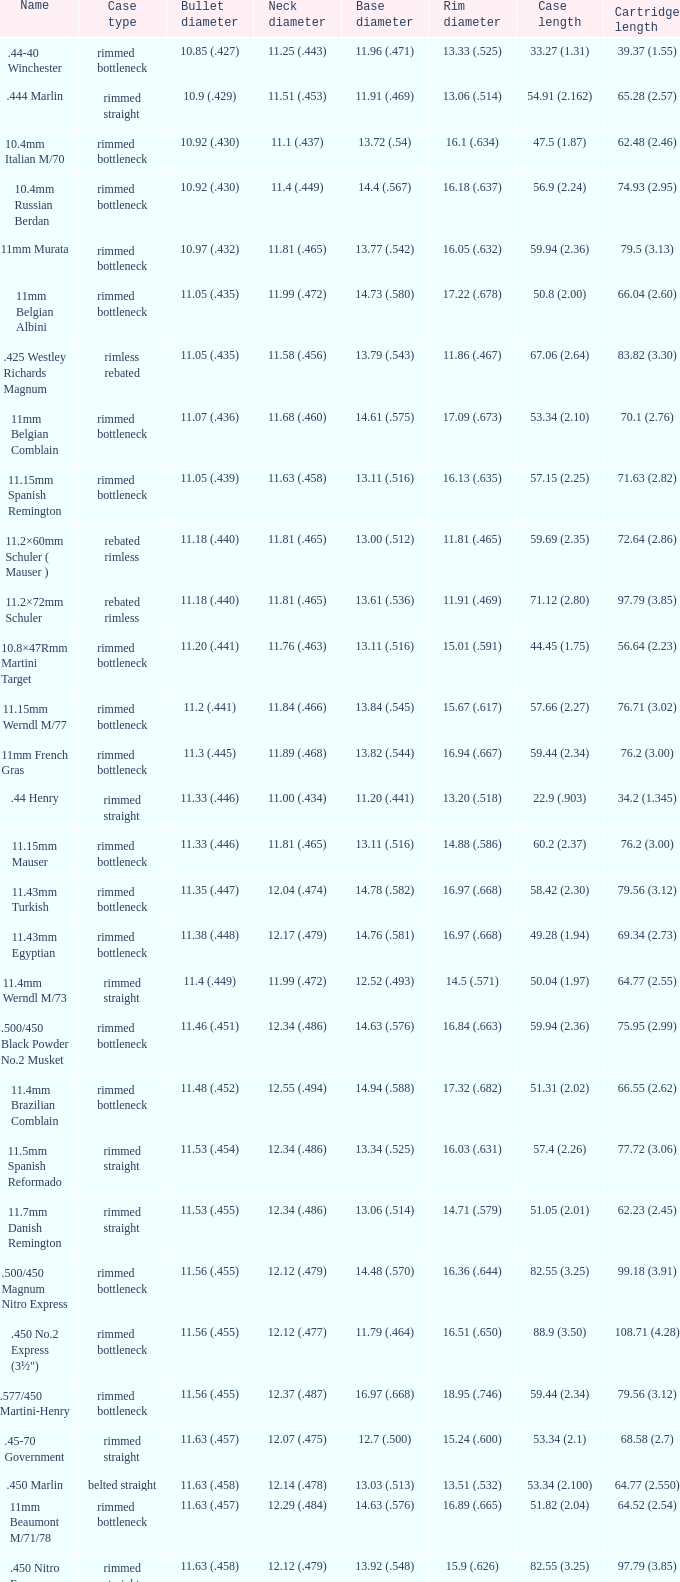Would you be able to parse every entry in this table? {'header': ['Name', 'Case type', 'Bullet diameter', 'Neck diameter', 'Base diameter', 'Rim diameter', 'Case length', 'Cartridge length'], 'rows': [['.44-40 Winchester', 'rimmed bottleneck', '10.85 (.427)', '11.25 (.443)', '11.96 (.471)', '13.33 (.525)', '33.27 (1.31)', '39.37 (1.55)'], ['.444 Marlin', 'rimmed straight', '10.9 (.429)', '11.51 (.453)', '11.91 (.469)', '13.06 (.514)', '54.91 (2.162)', '65.28 (2.57)'], ['10.4mm Italian M/70', 'rimmed bottleneck', '10.92 (.430)', '11.1 (.437)', '13.72 (.54)', '16.1 (.634)', '47.5 (1.87)', '62.48 (2.46)'], ['10.4mm Russian Berdan', 'rimmed bottleneck', '10.92 (.430)', '11.4 (.449)', '14.4 (.567)', '16.18 (.637)', '56.9 (2.24)', '74.93 (2.95)'], ['11mm Murata', 'rimmed bottleneck', '10.97 (.432)', '11.81 (.465)', '13.77 (.542)', '16.05 (.632)', '59.94 (2.36)', '79.5 (3.13)'], ['11mm Belgian Albini', 'rimmed bottleneck', '11.05 (.435)', '11.99 (.472)', '14.73 (.580)', '17.22 (.678)', '50.8 (2.00)', '66.04 (2.60)'], ['.425 Westley Richards Magnum', 'rimless rebated', '11.05 (.435)', '11.58 (.456)', '13.79 (.543)', '11.86 (.467)', '67.06 (2.64)', '83.82 (3.30)'], ['11mm Belgian Comblain', 'rimmed bottleneck', '11.07 (.436)', '11.68 (.460)', '14.61 (.575)', '17.09 (.673)', '53.34 (2.10)', '70.1 (2.76)'], ['11.15mm Spanish Remington', 'rimmed bottleneck', '11.05 (.439)', '11.63 (.458)', '13.11 (.516)', '16.13 (.635)', '57.15 (2.25)', '71.63 (2.82)'], ['11.2×60mm Schuler ( Mauser )', 'rebated rimless', '11.18 (.440)', '11.81 (.465)', '13.00 (.512)', '11.81 (.465)', '59.69 (2.35)', '72.64 (2.86)'], ['11.2×72mm Schuler', 'rebated rimless', '11.18 (.440)', '11.81 (.465)', '13.61 (.536)', '11.91 (.469)', '71.12 (2.80)', '97.79 (3.85)'], ['10.8×47Rmm Martini Target', 'rimmed bottleneck', '11.20 (.441)', '11.76 (.463)', '13.11 (.516)', '15.01 (.591)', '44.45 (1.75)', '56.64 (2.23)'], ['11.15mm Werndl M/77', 'rimmed bottleneck', '11.2 (.441)', '11.84 (.466)', '13.84 (.545)', '15.67 (.617)', '57.66 (2.27)', '76.71 (3.02)'], ['11mm French Gras', 'rimmed bottleneck', '11.3 (.445)', '11.89 (.468)', '13.82 (.544)', '16.94 (.667)', '59.44 (2.34)', '76.2 (3.00)'], ['.44 Henry', 'rimmed straight', '11.33 (.446)', '11.00 (.434)', '11.20 (.441)', '13.20 (.518)', '22.9 (.903)', '34.2 (1.345)'], ['11.15mm Mauser', 'rimmed bottleneck', '11.33 (.446)', '11.81 (.465)', '13.11 (.516)', '14.88 (.586)', '60.2 (2.37)', '76.2 (3.00)'], ['11.43mm Turkish', 'rimmed bottleneck', '11.35 (.447)', '12.04 (.474)', '14.78 (.582)', '16.97 (.668)', '58.42 (2.30)', '79.56 (3.12)'], ['11.43mm Egyptian', 'rimmed bottleneck', '11.38 (.448)', '12.17 (.479)', '14.76 (.581)', '16.97 (.668)', '49.28 (1.94)', '69.34 (2.73)'], ['11.4mm Werndl M/73', 'rimmed straight', '11.4 (.449)', '11.99 (.472)', '12.52 (.493)', '14.5 (.571)', '50.04 (1.97)', '64.77 (2.55)'], ['.500/450 Black Powder No.2 Musket', 'rimmed bottleneck', '11.46 (.451)', '12.34 (.486)', '14.63 (.576)', '16.84 (.663)', '59.94 (2.36)', '75.95 (2.99)'], ['11.4mm Brazilian Comblain', 'rimmed bottleneck', '11.48 (.452)', '12.55 (.494)', '14.94 (.588)', '17.32 (.682)', '51.31 (2.02)', '66.55 (2.62)'], ['11.5mm Spanish Reformado', 'rimmed straight', '11.53 (.454)', '12.34 (.486)', '13.34 (.525)', '16.03 (.631)', '57.4 (2.26)', '77.72 (3.06)'], ['11.7mm Danish Remington', 'rimmed straight', '11.53 (.455)', '12.34 (.486)', '13.06 (.514)', '14.71 (.579)', '51.05 (2.01)', '62.23 (2.45)'], ['.500/450 Magnum Nitro Express', 'rimmed bottleneck', '11.56 (.455)', '12.12 (.479)', '14.48 (.570)', '16.36 (.644)', '82.55 (3.25)', '99.18 (3.91)'], ['.450 No.2 Express (3½")', 'rimmed bottleneck', '11.56 (.455)', '12.12 (.477)', '11.79 (.464)', '16.51 (.650)', '88.9 (3.50)', '108.71 (4.28)'], ['.577/450 Martini-Henry', 'rimmed bottleneck', '11.56 (.455)', '12.37 (.487)', '16.97 (.668)', '18.95 (.746)', '59.44 (2.34)', '79.56 (3.12)'], ['.45-70 Government', 'rimmed straight', '11.63 (.457)', '12.07 (.475)', '12.7 (.500)', '15.24 (.600)', '53.34 (2.1)', '68.58 (2.7)'], ['.450 Marlin', 'belted straight', '11.63 (.458)', '12.14 (.478)', '13.03 (.513)', '13.51 (.532)', '53.34 (2.100)', '64.77 (2.550)'], ['11mm Beaumont M/71/78', 'rimmed bottleneck', '11.63 (.457)', '12.29 (.484)', '14.63 (.576)', '16.89 (.665)', '51.82 (2.04)', '64.52 (2.54)'], ['.450 Nitro Express (3¼")', 'rimmed straight', '11.63 (.458)', '12.12 (.479)', '13.92 (.548)', '15.9 (.626)', '82.55 (3.25)', '97.79 (3.85)'], ['.458 Winchester Magnum', 'belted straight', '11.63 (.458)', '12.14 (.478)', '13.03 (.513)', '13.51 (.532)', '63.5 (2.5)', '82.55 (3.350)'], ['.460 Weatherby Magnum', 'belted bottleneck', '11.63 (.458)', '12.32 (.485)', '14.80 (.583)', '13.54 (.533)', '74 (2.91)', '95.25 (3.75)'], ['.500/450 No.1 Express', 'rimmed bottleneck', '11.63 (.458)', '12.32 (.485)', '14.66 (.577)', '16.76 (.660)', '69.85 (2.75)', '82.55 (3.25)'], ['.450 Rigby Rimless', 'rimless bottleneck', '11.63 (.458)', '12.38 (.487)', '14.66 (.577)', '14.99 (.590)', '73.50 (2.89)', '95.00 (3.74)'], ['11.3mm Beaumont M/71', 'rimmed bottleneck', '11.63 (.464)', '12.34 (.486)', '14.76 (.581)', '16.92 (.666)', '50.04 (1.97)', '63.25 (2.49)'], ['.500/465 Nitro Express', 'rimmed bottleneck', '11.84 (.466)', '12.39 (.488)', '14.55 (.573)', '16.51 (.650)', '82.3 (3.24)', '98.04 (3.89)']]} 17 (.479)? 11.38 (.448). 